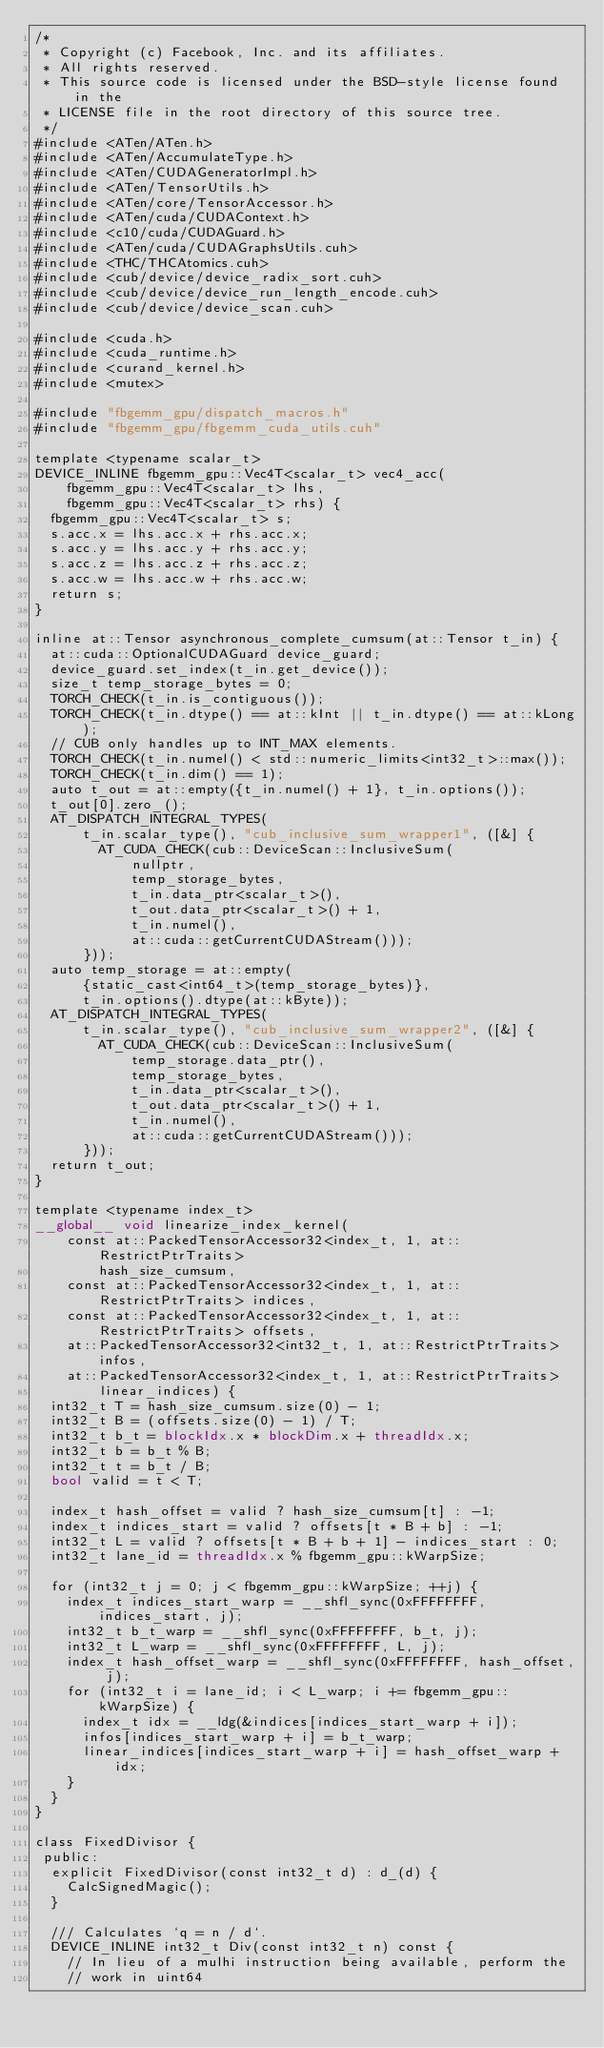Convert code to text. <code><loc_0><loc_0><loc_500><loc_500><_Cuda_>/*
 * Copyright (c) Facebook, Inc. and its affiliates.
 * All rights reserved.
 * This source code is licensed under the BSD-style license found in the
 * LICENSE file in the root directory of this source tree.
 */
#include <ATen/ATen.h>
#include <ATen/AccumulateType.h>
#include <ATen/CUDAGeneratorImpl.h>
#include <ATen/TensorUtils.h>
#include <ATen/core/TensorAccessor.h>
#include <ATen/cuda/CUDAContext.h>
#include <c10/cuda/CUDAGuard.h>
#include <ATen/cuda/CUDAGraphsUtils.cuh>
#include <THC/THCAtomics.cuh>
#include <cub/device/device_radix_sort.cuh>
#include <cub/device/device_run_length_encode.cuh>
#include <cub/device/device_scan.cuh>

#include <cuda.h>
#include <cuda_runtime.h>
#include <curand_kernel.h>
#include <mutex>

#include "fbgemm_gpu/dispatch_macros.h"
#include "fbgemm_gpu/fbgemm_cuda_utils.cuh"

template <typename scalar_t>
DEVICE_INLINE fbgemm_gpu::Vec4T<scalar_t> vec4_acc(
    fbgemm_gpu::Vec4T<scalar_t> lhs,
    fbgemm_gpu::Vec4T<scalar_t> rhs) {
  fbgemm_gpu::Vec4T<scalar_t> s;
  s.acc.x = lhs.acc.x + rhs.acc.x;
  s.acc.y = lhs.acc.y + rhs.acc.y;
  s.acc.z = lhs.acc.z + rhs.acc.z;
  s.acc.w = lhs.acc.w + rhs.acc.w;
  return s;
}

inline at::Tensor asynchronous_complete_cumsum(at::Tensor t_in) {
  at::cuda::OptionalCUDAGuard device_guard;
  device_guard.set_index(t_in.get_device());
  size_t temp_storage_bytes = 0;
  TORCH_CHECK(t_in.is_contiguous());
  TORCH_CHECK(t_in.dtype() == at::kInt || t_in.dtype() == at::kLong);
  // CUB only handles up to INT_MAX elements.
  TORCH_CHECK(t_in.numel() < std::numeric_limits<int32_t>::max());
  TORCH_CHECK(t_in.dim() == 1);
  auto t_out = at::empty({t_in.numel() + 1}, t_in.options());
  t_out[0].zero_();
  AT_DISPATCH_INTEGRAL_TYPES(
      t_in.scalar_type(), "cub_inclusive_sum_wrapper1", ([&] {
        AT_CUDA_CHECK(cub::DeviceScan::InclusiveSum(
            nullptr,
            temp_storage_bytes,
            t_in.data_ptr<scalar_t>(),
            t_out.data_ptr<scalar_t>() + 1,
            t_in.numel(),
            at::cuda::getCurrentCUDAStream()));
      }));
  auto temp_storage = at::empty(
      {static_cast<int64_t>(temp_storage_bytes)},
      t_in.options().dtype(at::kByte));
  AT_DISPATCH_INTEGRAL_TYPES(
      t_in.scalar_type(), "cub_inclusive_sum_wrapper2", ([&] {
        AT_CUDA_CHECK(cub::DeviceScan::InclusiveSum(
            temp_storage.data_ptr(),
            temp_storage_bytes,
            t_in.data_ptr<scalar_t>(),
            t_out.data_ptr<scalar_t>() + 1,
            t_in.numel(),
            at::cuda::getCurrentCUDAStream()));
      }));
  return t_out;
}

template <typename index_t>
__global__ void linearize_index_kernel(
    const at::PackedTensorAccessor32<index_t, 1, at::RestrictPtrTraits>
        hash_size_cumsum,
    const at::PackedTensorAccessor32<index_t, 1, at::RestrictPtrTraits> indices,
    const at::PackedTensorAccessor32<index_t, 1, at::RestrictPtrTraits> offsets,
    at::PackedTensorAccessor32<int32_t, 1, at::RestrictPtrTraits> infos,
    at::PackedTensorAccessor32<index_t, 1, at::RestrictPtrTraits>
        linear_indices) {
  int32_t T = hash_size_cumsum.size(0) - 1;
  int32_t B = (offsets.size(0) - 1) / T;
  int32_t b_t = blockIdx.x * blockDim.x + threadIdx.x;
  int32_t b = b_t % B;
  int32_t t = b_t / B;
  bool valid = t < T;

  index_t hash_offset = valid ? hash_size_cumsum[t] : -1;
  index_t indices_start = valid ? offsets[t * B + b] : -1;
  int32_t L = valid ? offsets[t * B + b + 1] - indices_start : 0;
  int32_t lane_id = threadIdx.x % fbgemm_gpu::kWarpSize;

  for (int32_t j = 0; j < fbgemm_gpu::kWarpSize; ++j) {
    index_t indices_start_warp = __shfl_sync(0xFFFFFFFF, indices_start, j);
    int32_t b_t_warp = __shfl_sync(0xFFFFFFFF, b_t, j);
    int32_t L_warp = __shfl_sync(0xFFFFFFFF, L, j);
    index_t hash_offset_warp = __shfl_sync(0xFFFFFFFF, hash_offset, j);
    for (int32_t i = lane_id; i < L_warp; i += fbgemm_gpu::kWarpSize) {
      index_t idx = __ldg(&indices[indices_start_warp + i]);
      infos[indices_start_warp + i] = b_t_warp;
      linear_indices[indices_start_warp + i] = hash_offset_warp + idx;
    }
  }
}

class FixedDivisor {
 public:
  explicit FixedDivisor(const int32_t d) : d_(d) {
    CalcSignedMagic();
  }

  /// Calculates `q = n / d`.
  DEVICE_INLINE int32_t Div(const int32_t n) const {
    // In lieu of a mulhi instruction being available, perform the
    // work in uint64</code> 